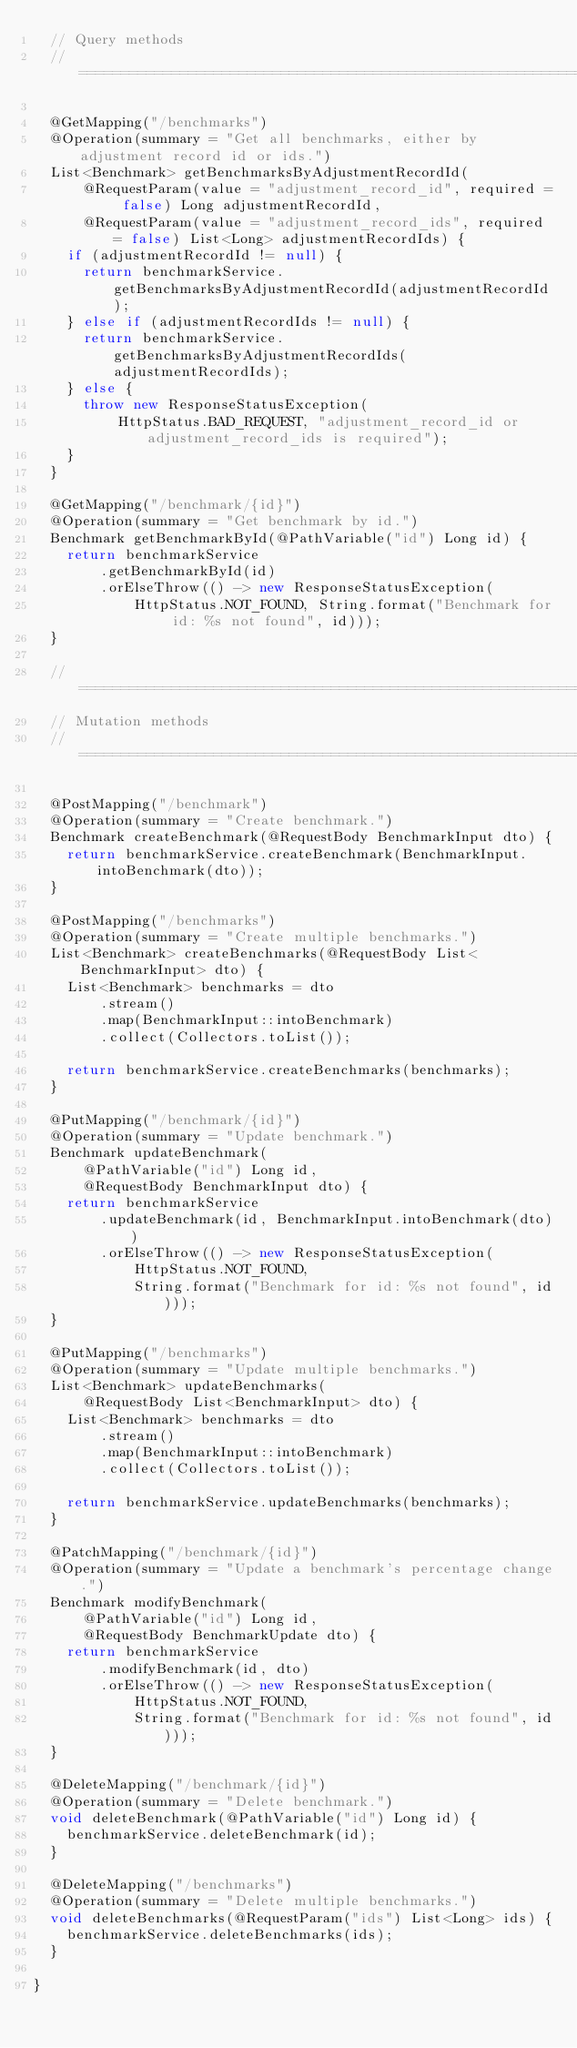Convert code to text. <code><loc_0><loc_0><loc_500><loc_500><_Java_>  // Query methods
  // =======================================================================

  @GetMapping("/benchmarks")
  @Operation(summary = "Get all benchmarks, either by adjustment record id or ids.")
  List<Benchmark> getBenchmarksByAdjustmentRecordId(
      @RequestParam(value = "adjustment_record_id", required = false) Long adjustmentRecordId,
      @RequestParam(value = "adjustment_record_ids", required = false) List<Long> adjustmentRecordIds) {
    if (adjustmentRecordId != null) {
      return benchmarkService.getBenchmarksByAdjustmentRecordId(adjustmentRecordId);
    } else if (adjustmentRecordIds != null) {
      return benchmarkService.getBenchmarksByAdjustmentRecordIds(adjustmentRecordIds);
    } else {
      throw new ResponseStatusException(
          HttpStatus.BAD_REQUEST, "adjustment_record_id or adjustment_record_ids is required");
    }
  }

  @GetMapping("/benchmark/{id}")
  @Operation(summary = "Get benchmark by id.")
  Benchmark getBenchmarkById(@PathVariable("id") Long id) {
    return benchmarkService
        .getBenchmarkById(id)
        .orElseThrow(() -> new ResponseStatusException(
            HttpStatus.NOT_FOUND, String.format("Benchmark for id: %s not found", id)));
  }

  // =======================================================================
  // Mutation methods
  // =======================================================================

  @PostMapping("/benchmark")
  @Operation(summary = "Create benchmark.")
  Benchmark createBenchmark(@RequestBody BenchmarkInput dto) {
    return benchmarkService.createBenchmark(BenchmarkInput.intoBenchmark(dto));
  }

  @PostMapping("/benchmarks")
  @Operation(summary = "Create multiple benchmarks.")
  List<Benchmark> createBenchmarks(@RequestBody List<BenchmarkInput> dto) {
    List<Benchmark> benchmarks = dto
        .stream()
        .map(BenchmarkInput::intoBenchmark)
        .collect(Collectors.toList());

    return benchmarkService.createBenchmarks(benchmarks);
  }

  @PutMapping("/benchmark/{id}")
  @Operation(summary = "Update benchmark.")
  Benchmark updateBenchmark(
      @PathVariable("id") Long id,
      @RequestBody BenchmarkInput dto) {
    return benchmarkService
        .updateBenchmark(id, BenchmarkInput.intoBenchmark(dto))
        .orElseThrow(() -> new ResponseStatusException(
            HttpStatus.NOT_FOUND,
            String.format("Benchmark for id: %s not found", id)));
  }

  @PutMapping("/benchmarks")
  @Operation(summary = "Update multiple benchmarks.")
  List<Benchmark> updateBenchmarks(
      @RequestBody List<BenchmarkInput> dto) {
    List<Benchmark> benchmarks = dto
        .stream()
        .map(BenchmarkInput::intoBenchmark)
        .collect(Collectors.toList());

    return benchmarkService.updateBenchmarks(benchmarks);
  }

  @PatchMapping("/benchmark/{id}")
  @Operation(summary = "Update a benchmark's percentage change.")
  Benchmark modifyBenchmark(
      @PathVariable("id") Long id,
      @RequestBody BenchmarkUpdate dto) {
    return benchmarkService
        .modifyBenchmark(id, dto)
        .orElseThrow(() -> new ResponseStatusException(
            HttpStatus.NOT_FOUND,
            String.format("Benchmark for id: %s not found", id)));
  }

  @DeleteMapping("/benchmark/{id}")
  @Operation(summary = "Delete benchmark.")
  void deleteBenchmark(@PathVariable("id") Long id) {
    benchmarkService.deleteBenchmark(id);
  }

  @DeleteMapping("/benchmarks")
  @Operation(summary = "Delete multiple benchmarks.")
  void deleteBenchmarks(@RequestParam("ids") List<Long> ids) {
    benchmarkService.deleteBenchmarks(ids);
  }

}
</code> 